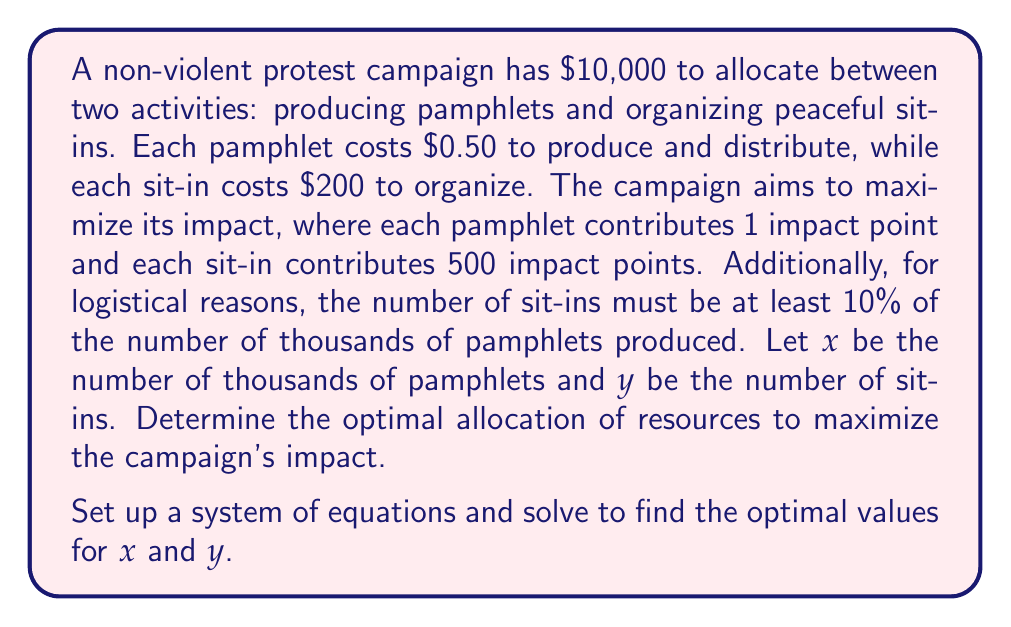Solve this math problem. Let's approach this step-by-step:

1) First, let's set up our constraints:

   Budget constraint: $500x + 200y \leq 10000$
   Logistical constraint: $y \geq 0.1x$

2) Our objective function (impact) is:
   
   $I = 1000x + 500y$ (note that $x$ is in thousands)

3) We want to maximize $I$ subject to our constraints. To do this, we'll use the fact that at the optimal point, the budget constraint will be an equality:

   $500x + 200y = 10000$

4) We can express $y$ in terms of $x$ from this equation:

   $y = 50 - 2.5x$

5) Substituting this into our logistical constraint:

   $50 - 2.5x \geq 0.1x$
   $50 \geq 2.6x$
   $x \leq 19.23$

6) Now, let's substitute $y = 50 - 2.5x$ into our impact function:

   $I = 1000x + 500(50 - 2.5x) = 1000x + 25000 - 1250x = 25000 - 250x$

7) This is a linear function in $x$, and we want to maximize it subject to $0 \leq x \leq 19.23$. The maximum will occur at one of the endpoints.

8) At $x = 0$: $I = 25000$
   At $x = 19.23$: $I = 25000 - 250(19.23) = 20192.5$

9) Therefore, the maximum impact occurs at $x = 0$, which means $y = 50$.

10) Checking our constraints:
    Budget: $200(50) = 10000$ (satisfied)
    Logistical: $50 \geq 0.1(0)$ (satisfied)

Thus, the optimal allocation is to organize 50 sit-ins and produce no pamphlets.
Answer: $x = 0, y = 50$ 